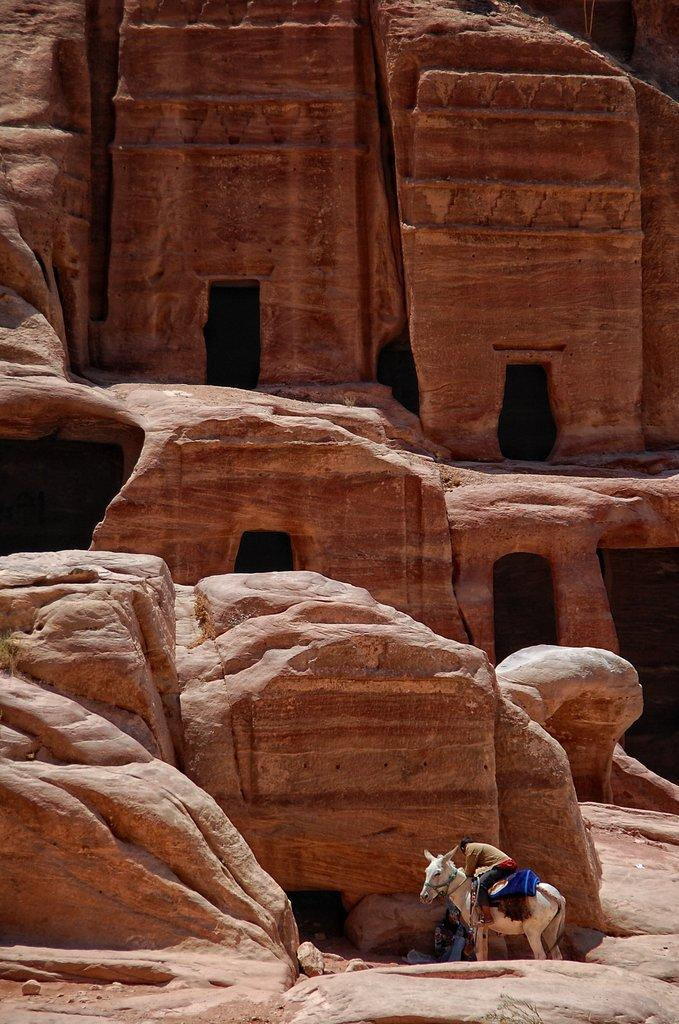What type of natural formation can be seen in the image? There are rocks in the image. What is the person in the image doing? The person is sitting on a white horse in the image. What type of pie is being served on the rocks in the image? There is no pie present in the image; it features rocks and a person sitting on a white horse. What brother of the person in the image is also present in the image? There is no brother of the person in the image, as the image only shows a person sitting on a white horse and rocks. 